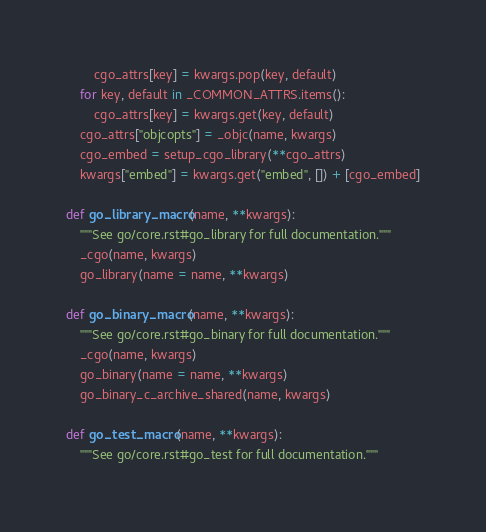<code> <loc_0><loc_0><loc_500><loc_500><_Python_>        cgo_attrs[key] = kwargs.pop(key, default)
    for key, default in _COMMON_ATTRS.items():
        cgo_attrs[key] = kwargs.get(key, default)
    cgo_attrs["objcopts"] = _objc(name, kwargs)
    cgo_embed = setup_cgo_library(**cgo_attrs)
    kwargs["embed"] = kwargs.get("embed", []) + [cgo_embed]

def go_library_macro(name, **kwargs):
    """See go/core.rst#go_library for full documentation."""
    _cgo(name, kwargs)
    go_library(name = name, **kwargs)

def go_binary_macro(name, **kwargs):
    """See go/core.rst#go_binary for full documentation."""
    _cgo(name, kwargs)
    go_binary(name = name, **kwargs)
    go_binary_c_archive_shared(name, kwargs)

def go_test_macro(name, **kwargs):
    """See go/core.rst#go_test for full documentation."""</code> 